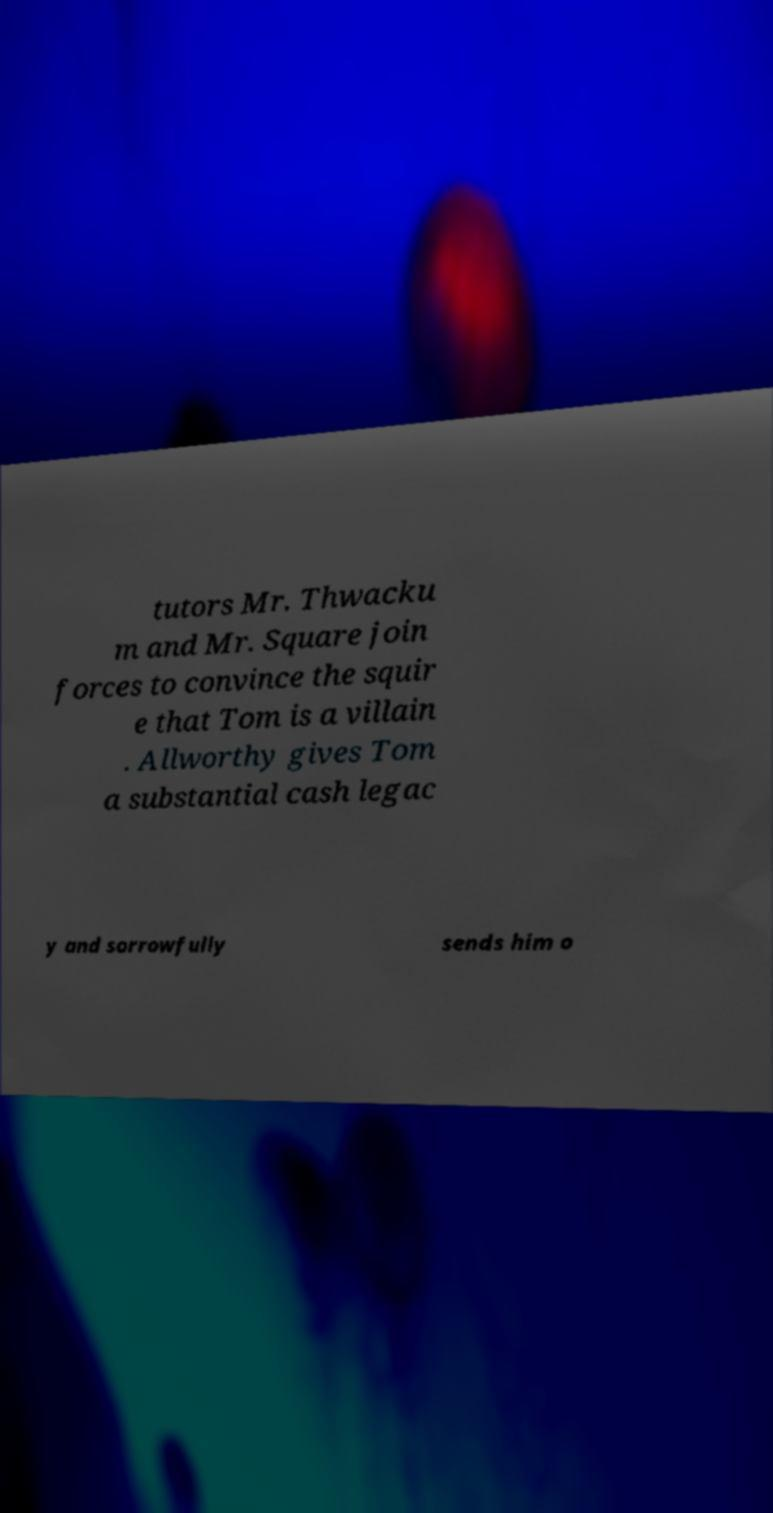Could you assist in decoding the text presented in this image and type it out clearly? tutors Mr. Thwacku m and Mr. Square join forces to convince the squir e that Tom is a villain . Allworthy gives Tom a substantial cash legac y and sorrowfully sends him o 